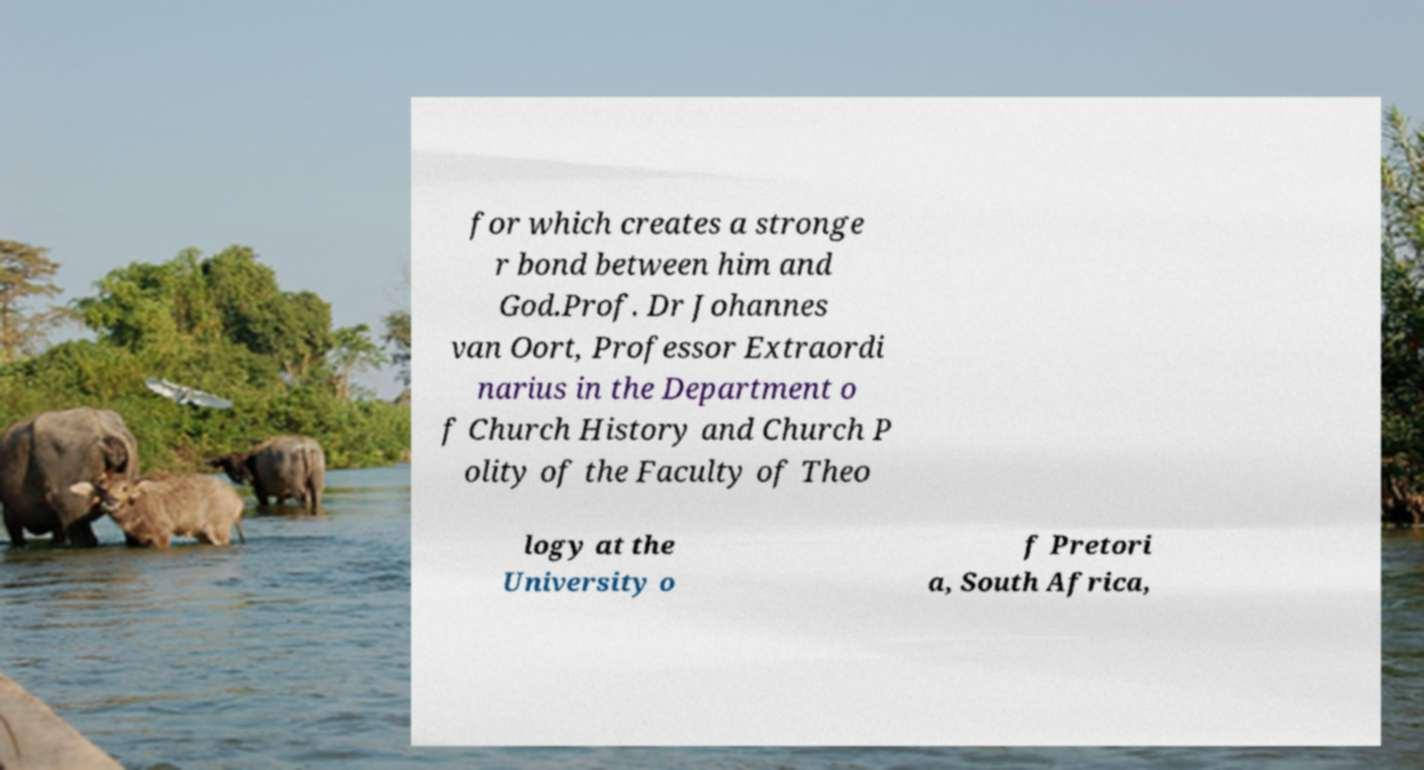Can you read and provide the text displayed in the image?This photo seems to have some interesting text. Can you extract and type it out for me? for which creates a stronge r bond between him and God.Prof. Dr Johannes van Oort, Professor Extraordi narius in the Department o f Church History and Church P olity of the Faculty of Theo logy at the University o f Pretori a, South Africa, 